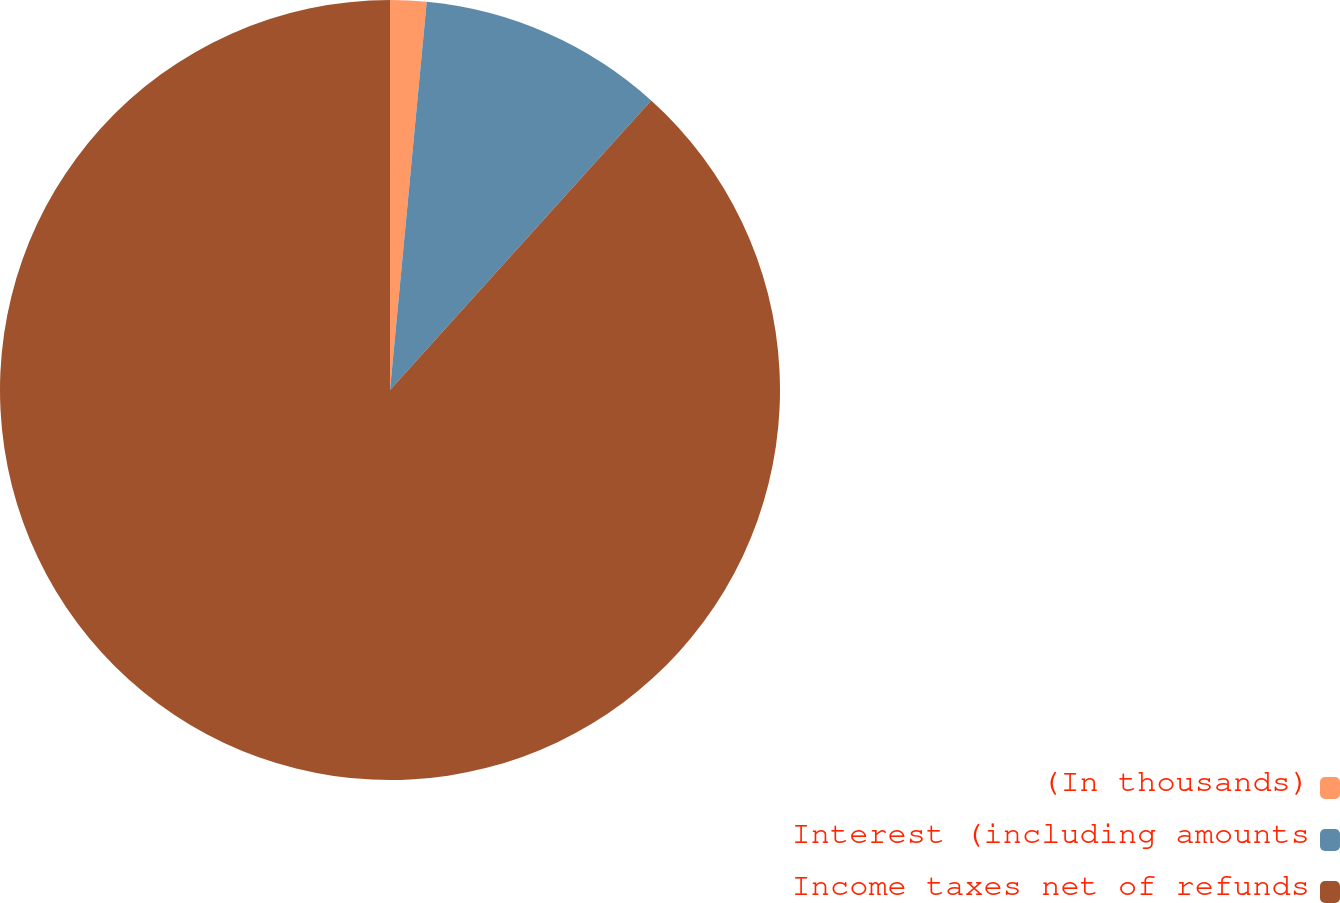<chart> <loc_0><loc_0><loc_500><loc_500><pie_chart><fcel>(In thousands)<fcel>Interest (including amounts<fcel>Income taxes net of refunds<nl><fcel>1.5%<fcel>10.18%<fcel>88.31%<nl></chart> 